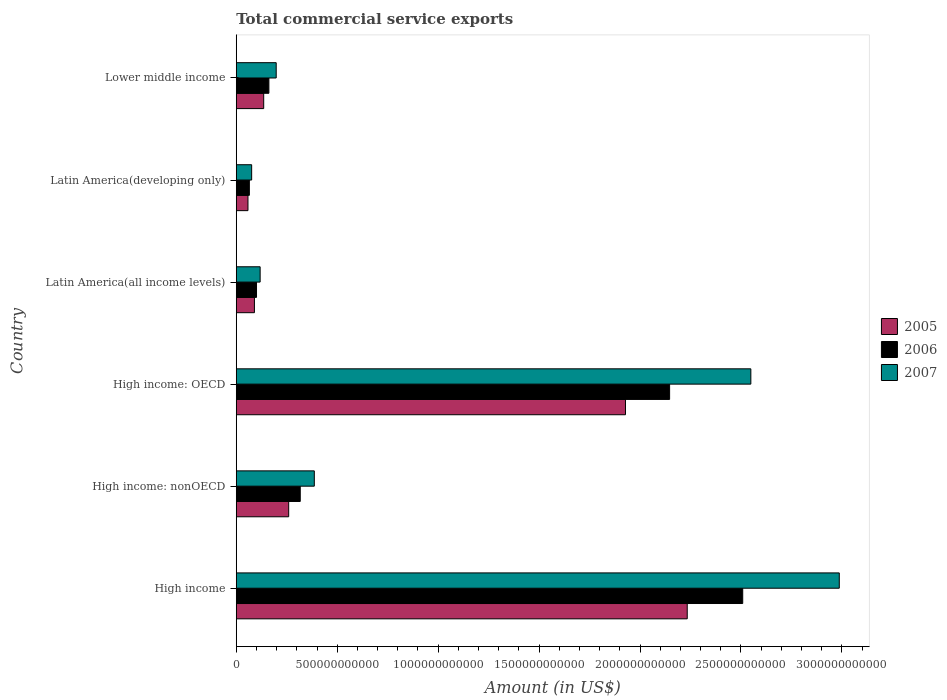Are the number of bars per tick equal to the number of legend labels?
Provide a succinct answer. Yes. How many bars are there on the 6th tick from the top?
Ensure brevity in your answer.  3. What is the label of the 6th group of bars from the top?
Keep it short and to the point. High income. What is the total commercial service exports in 2006 in Latin America(developing only)?
Provide a succinct answer. 6.49e+1. Across all countries, what is the maximum total commercial service exports in 2005?
Make the answer very short. 2.23e+12. Across all countries, what is the minimum total commercial service exports in 2006?
Your answer should be very brief. 6.49e+1. In which country was the total commercial service exports in 2006 minimum?
Make the answer very short. Latin America(developing only). What is the total total commercial service exports in 2005 in the graph?
Provide a short and direct response. 4.71e+12. What is the difference between the total commercial service exports in 2007 in High income: OECD and that in Latin America(developing only)?
Provide a short and direct response. 2.47e+12. What is the difference between the total commercial service exports in 2006 in High income: OECD and the total commercial service exports in 2005 in High income: nonOECD?
Provide a short and direct response. 1.89e+12. What is the average total commercial service exports in 2005 per country?
Your answer should be very brief. 7.84e+11. What is the difference between the total commercial service exports in 2007 and total commercial service exports in 2006 in Lower middle income?
Provide a short and direct response. 3.62e+1. What is the ratio of the total commercial service exports in 2005 in High income: OECD to that in Lower middle income?
Your answer should be compact. 14.18. Is the difference between the total commercial service exports in 2007 in High income and High income: OECD greater than the difference between the total commercial service exports in 2006 in High income and High income: OECD?
Give a very brief answer. Yes. What is the difference between the highest and the second highest total commercial service exports in 2006?
Your answer should be very brief. 3.62e+11. What is the difference between the highest and the lowest total commercial service exports in 2007?
Make the answer very short. 2.91e+12. Is the sum of the total commercial service exports in 2005 in High income and High income: OECD greater than the maximum total commercial service exports in 2006 across all countries?
Your answer should be compact. Yes. What does the 2nd bar from the top in High income represents?
Your response must be concise. 2006. Is it the case that in every country, the sum of the total commercial service exports in 2006 and total commercial service exports in 2005 is greater than the total commercial service exports in 2007?
Give a very brief answer. Yes. How many bars are there?
Provide a short and direct response. 18. Are all the bars in the graph horizontal?
Provide a short and direct response. Yes. How many countries are there in the graph?
Your response must be concise. 6. What is the difference between two consecutive major ticks on the X-axis?
Your response must be concise. 5.00e+11. Are the values on the major ticks of X-axis written in scientific E-notation?
Offer a very short reply. No. Does the graph contain any zero values?
Provide a succinct answer. No. Does the graph contain grids?
Provide a short and direct response. No. Where does the legend appear in the graph?
Offer a terse response. Center right. How are the legend labels stacked?
Give a very brief answer. Vertical. What is the title of the graph?
Your answer should be compact. Total commercial service exports. Does "1981" appear as one of the legend labels in the graph?
Your answer should be compact. No. What is the label or title of the X-axis?
Give a very brief answer. Amount (in US$). What is the Amount (in US$) in 2005 in High income?
Offer a very short reply. 2.23e+12. What is the Amount (in US$) of 2006 in High income?
Offer a very short reply. 2.51e+12. What is the Amount (in US$) of 2007 in High income?
Offer a very short reply. 2.99e+12. What is the Amount (in US$) in 2005 in High income: nonOECD?
Your answer should be very brief. 2.60e+11. What is the Amount (in US$) of 2006 in High income: nonOECD?
Keep it short and to the point. 3.17e+11. What is the Amount (in US$) in 2007 in High income: nonOECD?
Offer a terse response. 3.87e+11. What is the Amount (in US$) of 2005 in High income: OECD?
Offer a very short reply. 1.93e+12. What is the Amount (in US$) of 2006 in High income: OECD?
Your response must be concise. 2.15e+12. What is the Amount (in US$) in 2007 in High income: OECD?
Provide a short and direct response. 2.55e+12. What is the Amount (in US$) of 2005 in Latin America(all income levels)?
Ensure brevity in your answer.  9.00e+1. What is the Amount (in US$) of 2006 in Latin America(all income levels)?
Your answer should be very brief. 1.00e+11. What is the Amount (in US$) of 2007 in Latin America(all income levels)?
Offer a terse response. 1.18e+11. What is the Amount (in US$) in 2005 in Latin America(developing only)?
Your response must be concise. 5.80e+1. What is the Amount (in US$) in 2006 in Latin America(developing only)?
Make the answer very short. 6.49e+1. What is the Amount (in US$) of 2007 in Latin America(developing only)?
Provide a short and direct response. 7.63e+1. What is the Amount (in US$) in 2005 in Lower middle income?
Keep it short and to the point. 1.36e+11. What is the Amount (in US$) in 2006 in Lower middle income?
Make the answer very short. 1.62e+11. What is the Amount (in US$) of 2007 in Lower middle income?
Your answer should be very brief. 1.98e+11. Across all countries, what is the maximum Amount (in US$) in 2005?
Provide a succinct answer. 2.23e+12. Across all countries, what is the maximum Amount (in US$) of 2006?
Your answer should be compact. 2.51e+12. Across all countries, what is the maximum Amount (in US$) of 2007?
Offer a terse response. 2.99e+12. Across all countries, what is the minimum Amount (in US$) of 2005?
Keep it short and to the point. 5.80e+1. Across all countries, what is the minimum Amount (in US$) of 2006?
Your response must be concise. 6.49e+1. Across all countries, what is the minimum Amount (in US$) of 2007?
Your response must be concise. 7.63e+1. What is the total Amount (in US$) in 2005 in the graph?
Offer a terse response. 4.71e+12. What is the total Amount (in US$) in 2006 in the graph?
Your response must be concise. 5.30e+12. What is the total Amount (in US$) of 2007 in the graph?
Provide a short and direct response. 6.31e+12. What is the difference between the Amount (in US$) in 2005 in High income and that in High income: nonOECD?
Ensure brevity in your answer.  1.97e+12. What is the difference between the Amount (in US$) of 2006 in High income and that in High income: nonOECD?
Make the answer very short. 2.19e+12. What is the difference between the Amount (in US$) of 2007 in High income and that in High income: nonOECD?
Keep it short and to the point. 2.60e+12. What is the difference between the Amount (in US$) of 2005 in High income and that in High income: OECD?
Give a very brief answer. 3.06e+11. What is the difference between the Amount (in US$) of 2006 in High income and that in High income: OECD?
Offer a very short reply. 3.62e+11. What is the difference between the Amount (in US$) of 2007 in High income and that in High income: OECD?
Offer a terse response. 4.38e+11. What is the difference between the Amount (in US$) in 2005 in High income and that in Latin America(all income levels)?
Your answer should be compact. 2.14e+12. What is the difference between the Amount (in US$) in 2006 in High income and that in Latin America(all income levels)?
Your response must be concise. 2.41e+12. What is the difference between the Amount (in US$) in 2007 in High income and that in Latin America(all income levels)?
Offer a terse response. 2.87e+12. What is the difference between the Amount (in US$) of 2005 in High income and that in Latin America(developing only)?
Keep it short and to the point. 2.18e+12. What is the difference between the Amount (in US$) in 2006 in High income and that in Latin America(developing only)?
Keep it short and to the point. 2.44e+12. What is the difference between the Amount (in US$) in 2007 in High income and that in Latin America(developing only)?
Provide a short and direct response. 2.91e+12. What is the difference between the Amount (in US$) of 2005 in High income and that in Lower middle income?
Provide a succinct answer. 2.10e+12. What is the difference between the Amount (in US$) in 2006 in High income and that in Lower middle income?
Offer a terse response. 2.35e+12. What is the difference between the Amount (in US$) of 2007 in High income and that in Lower middle income?
Make the answer very short. 2.79e+12. What is the difference between the Amount (in US$) of 2005 in High income: nonOECD and that in High income: OECD?
Offer a terse response. -1.67e+12. What is the difference between the Amount (in US$) in 2006 in High income: nonOECD and that in High income: OECD?
Your answer should be very brief. -1.83e+12. What is the difference between the Amount (in US$) of 2007 in High income: nonOECD and that in High income: OECD?
Your response must be concise. -2.16e+12. What is the difference between the Amount (in US$) in 2005 in High income: nonOECD and that in Latin America(all income levels)?
Offer a very short reply. 1.70e+11. What is the difference between the Amount (in US$) in 2006 in High income: nonOECD and that in Latin America(all income levels)?
Ensure brevity in your answer.  2.17e+11. What is the difference between the Amount (in US$) in 2007 in High income: nonOECD and that in Latin America(all income levels)?
Ensure brevity in your answer.  2.68e+11. What is the difference between the Amount (in US$) of 2005 in High income: nonOECD and that in Latin America(developing only)?
Make the answer very short. 2.02e+11. What is the difference between the Amount (in US$) of 2006 in High income: nonOECD and that in Latin America(developing only)?
Provide a succinct answer. 2.52e+11. What is the difference between the Amount (in US$) of 2007 in High income: nonOECD and that in Latin America(developing only)?
Offer a terse response. 3.10e+11. What is the difference between the Amount (in US$) in 2005 in High income: nonOECD and that in Lower middle income?
Your answer should be compact. 1.24e+11. What is the difference between the Amount (in US$) of 2006 in High income: nonOECD and that in Lower middle income?
Keep it short and to the point. 1.55e+11. What is the difference between the Amount (in US$) of 2007 in High income: nonOECD and that in Lower middle income?
Ensure brevity in your answer.  1.89e+11. What is the difference between the Amount (in US$) in 2005 in High income: OECD and that in Latin America(all income levels)?
Make the answer very short. 1.84e+12. What is the difference between the Amount (in US$) in 2006 in High income: OECD and that in Latin America(all income levels)?
Keep it short and to the point. 2.05e+12. What is the difference between the Amount (in US$) in 2007 in High income: OECD and that in Latin America(all income levels)?
Ensure brevity in your answer.  2.43e+12. What is the difference between the Amount (in US$) of 2005 in High income: OECD and that in Latin America(developing only)?
Offer a very short reply. 1.87e+12. What is the difference between the Amount (in US$) in 2006 in High income: OECD and that in Latin America(developing only)?
Offer a very short reply. 2.08e+12. What is the difference between the Amount (in US$) of 2007 in High income: OECD and that in Latin America(developing only)?
Keep it short and to the point. 2.47e+12. What is the difference between the Amount (in US$) in 2005 in High income: OECD and that in Lower middle income?
Your answer should be compact. 1.79e+12. What is the difference between the Amount (in US$) of 2006 in High income: OECD and that in Lower middle income?
Ensure brevity in your answer.  1.98e+12. What is the difference between the Amount (in US$) in 2007 in High income: OECD and that in Lower middle income?
Provide a short and direct response. 2.35e+12. What is the difference between the Amount (in US$) in 2005 in Latin America(all income levels) and that in Latin America(developing only)?
Offer a very short reply. 3.20e+1. What is the difference between the Amount (in US$) of 2006 in Latin America(all income levels) and that in Latin America(developing only)?
Provide a short and direct response. 3.54e+1. What is the difference between the Amount (in US$) of 2007 in Latin America(all income levels) and that in Latin America(developing only)?
Provide a short and direct response. 4.20e+1. What is the difference between the Amount (in US$) of 2005 in Latin America(all income levels) and that in Lower middle income?
Keep it short and to the point. -4.60e+1. What is the difference between the Amount (in US$) of 2006 in Latin America(all income levels) and that in Lower middle income?
Provide a short and direct response. -6.13e+1. What is the difference between the Amount (in US$) of 2007 in Latin America(all income levels) and that in Lower middle income?
Keep it short and to the point. -7.96e+1. What is the difference between the Amount (in US$) in 2005 in Latin America(developing only) and that in Lower middle income?
Provide a succinct answer. -7.80e+1. What is the difference between the Amount (in US$) in 2006 in Latin America(developing only) and that in Lower middle income?
Your answer should be very brief. -9.68e+1. What is the difference between the Amount (in US$) of 2007 in Latin America(developing only) and that in Lower middle income?
Offer a terse response. -1.22e+11. What is the difference between the Amount (in US$) in 2005 in High income and the Amount (in US$) in 2006 in High income: nonOECD?
Ensure brevity in your answer.  1.92e+12. What is the difference between the Amount (in US$) of 2005 in High income and the Amount (in US$) of 2007 in High income: nonOECD?
Give a very brief answer. 1.85e+12. What is the difference between the Amount (in US$) of 2006 in High income and the Amount (in US$) of 2007 in High income: nonOECD?
Your answer should be very brief. 2.12e+12. What is the difference between the Amount (in US$) of 2005 in High income and the Amount (in US$) of 2006 in High income: OECD?
Make the answer very short. 8.74e+1. What is the difference between the Amount (in US$) of 2005 in High income and the Amount (in US$) of 2007 in High income: OECD?
Provide a short and direct response. -3.15e+11. What is the difference between the Amount (in US$) in 2006 in High income and the Amount (in US$) in 2007 in High income: OECD?
Ensure brevity in your answer.  -4.02e+1. What is the difference between the Amount (in US$) of 2005 in High income and the Amount (in US$) of 2006 in Latin America(all income levels)?
Provide a succinct answer. 2.13e+12. What is the difference between the Amount (in US$) of 2005 in High income and the Amount (in US$) of 2007 in Latin America(all income levels)?
Keep it short and to the point. 2.12e+12. What is the difference between the Amount (in US$) of 2006 in High income and the Amount (in US$) of 2007 in Latin America(all income levels)?
Ensure brevity in your answer.  2.39e+12. What is the difference between the Amount (in US$) in 2005 in High income and the Amount (in US$) in 2006 in Latin America(developing only)?
Provide a succinct answer. 2.17e+12. What is the difference between the Amount (in US$) in 2005 in High income and the Amount (in US$) in 2007 in Latin America(developing only)?
Give a very brief answer. 2.16e+12. What is the difference between the Amount (in US$) in 2006 in High income and the Amount (in US$) in 2007 in Latin America(developing only)?
Ensure brevity in your answer.  2.43e+12. What is the difference between the Amount (in US$) in 2005 in High income and the Amount (in US$) in 2006 in Lower middle income?
Your answer should be very brief. 2.07e+12. What is the difference between the Amount (in US$) in 2005 in High income and the Amount (in US$) in 2007 in Lower middle income?
Keep it short and to the point. 2.04e+12. What is the difference between the Amount (in US$) in 2006 in High income and the Amount (in US$) in 2007 in Lower middle income?
Ensure brevity in your answer.  2.31e+12. What is the difference between the Amount (in US$) of 2005 in High income: nonOECD and the Amount (in US$) of 2006 in High income: OECD?
Make the answer very short. -1.89e+12. What is the difference between the Amount (in US$) of 2005 in High income: nonOECD and the Amount (in US$) of 2007 in High income: OECD?
Provide a short and direct response. -2.29e+12. What is the difference between the Amount (in US$) of 2006 in High income: nonOECD and the Amount (in US$) of 2007 in High income: OECD?
Make the answer very short. -2.23e+12. What is the difference between the Amount (in US$) of 2005 in High income: nonOECD and the Amount (in US$) of 2006 in Latin America(all income levels)?
Keep it short and to the point. 1.59e+11. What is the difference between the Amount (in US$) in 2005 in High income: nonOECD and the Amount (in US$) in 2007 in Latin America(all income levels)?
Make the answer very short. 1.41e+11. What is the difference between the Amount (in US$) in 2006 in High income: nonOECD and the Amount (in US$) in 2007 in Latin America(all income levels)?
Give a very brief answer. 1.99e+11. What is the difference between the Amount (in US$) of 2005 in High income: nonOECD and the Amount (in US$) of 2006 in Latin America(developing only)?
Make the answer very short. 1.95e+11. What is the difference between the Amount (in US$) in 2005 in High income: nonOECD and the Amount (in US$) in 2007 in Latin America(developing only)?
Provide a short and direct response. 1.83e+11. What is the difference between the Amount (in US$) in 2006 in High income: nonOECD and the Amount (in US$) in 2007 in Latin America(developing only)?
Your answer should be very brief. 2.41e+11. What is the difference between the Amount (in US$) in 2005 in High income: nonOECD and the Amount (in US$) in 2006 in Lower middle income?
Your answer should be compact. 9.80e+1. What is the difference between the Amount (in US$) of 2005 in High income: nonOECD and the Amount (in US$) of 2007 in Lower middle income?
Provide a short and direct response. 6.18e+1. What is the difference between the Amount (in US$) in 2006 in High income: nonOECD and the Amount (in US$) in 2007 in Lower middle income?
Your answer should be very brief. 1.19e+11. What is the difference between the Amount (in US$) in 2005 in High income: OECD and the Amount (in US$) in 2006 in Latin America(all income levels)?
Give a very brief answer. 1.83e+12. What is the difference between the Amount (in US$) in 2005 in High income: OECD and the Amount (in US$) in 2007 in Latin America(all income levels)?
Provide a short and direct response. 1.81e+12. What is the difference between the Amount (in US$) of 2006 in High income: OECD and the Amount (in US$) of 2007 in Latin America(all income levels)?
Offer a terse response. 2.03e+12. What is the difference between the Amount (in US$) in 2005 in High income: OECD and the Amount (in US$) in 2006 in Latin America(developing only)?
Your response must be concise. 1.86e+12. What is the difference between the Amount (in US$) in 2005 in High income: OECD and the Amount (in US$) in 2007 in Latin America(developing only)?
Keep it short and to the point. 1.85e+12. What is the difference between the Amount (in US$) in 2006 in High income: OECD and the Amount (in US$) in 2007 in Latin America(developing only)?
Your response must be concise. 2.07e+12. What is the difference between the Amount (in US$) of 2005 in High income: OECD and the Amount (in US$) of 2006 in Lower middle income?
Ensure brevity in your answer.  1.77e+12. What is the difference between the Amount (in US$) of 2005 in High income: OECD and the Amount (in US$) of 2007 in Lower middle income?
Keep it short and to the point. 1.73e+12. What is the difference between the Amount (in US$) in 2006 in High income: OECD and the Amount (in US$) in 2007 in Lower middle income?
Ensure brevity in your answer.  1.95e+12. What is the difference between the Amount (in US$) of 2005 in Latin America(all income levels) and the Amount (in US$) of 2006 in Latin America(developing only)?
Your answer should be very brief. 2.51e+1. What is the difference between the Amount (in US$) of 2005 in Latin America(all income levels) and the Amount (in US$) of 2007 in Latin America(developing only)?
Make the answer very short. 1.37e+1. What is the difference between the Amount (in US$) of 2006 in Latin America(all income levels) and the Amount (in US$) of 2007 in Latin America(developing only)?
Your answer should be compact. 2.40e+1. What is the difference between the Amount (in US$) in 2005 in Latin America(all income levels) and the Amount (in US$) in 2006 in Lower middle income?
Your answer should be very brief. -7.16e+1. What is the difference between the Amount (in US$) of 2005 in Latin America(all income levels) and the Amount (in US$) of 2007 in Lower middle income?
Your answer should be very brief. -1.08e+11. What is the difference between the Amount (in US$) in 2006 in Latin America(all income levels) and the Amount (in US$) in 2007 in Lower middle income?
Provide a succinct answer. -9.75e+1. What is the difference between the Amount (in US$) of 2005 in Latin America(developing only) and the Amount (in US$) of 2006 in Lower middle income?
Make the answer very short. -1.04e+11. What is the difference between the Amount (in US$) of 2005 in Latin America(developing only) and the Amount (in US$) of 2007 in Lower middle income?
Ensure brevity in your answer.  -1.40e+11. What is the difference between the Amount (in US$) in 2006 in Latin America(developing only) and the Amount (in US$) in 2007 in Lower middle income?
Your answer should be compact. -1.33e+11. What is the average Amount (in US$) in 2005 per country?
Ensure brevity in your answer.  7.84e+11. What is the average Amount (in US$) of 2006 per country?
Make the answer very short. 8.83e+11. What is the average Amount (in US$) of 2007 per country?
Give a very brief answer. 1.05e+12. What is the difference between the Amount (in US$) in 2005 and Amount (in US$) in 2006 in High income?
Your answer should be very brief. -2.75e+11. What is the difference between the Amount (in US$) of 2005 and Amount (in US$) of 2007 in High income?
Your response must be concise. -7.53e+11. What is the difference between the Amount (in US$) in 2006 and Amount (in US$) in 2007 in High income?
Make the answer very short. -4.78e+11. What is the difference between the Amount (in US$) of 2005 and Amount (in US$) of 2006 in High income: nonOECD?
Your response must be concise. -5.73e+1. What is the difference between the Amount (in US$) in 2005 and Amount (in US$) in 2007 in High income: nonOECD?
Provide a short and direct response. -1.27e+11. What is the difference between the Amount (in US$) in 2006 and Amount (in US$) in 2007 in High income: nonOECD?
Provide a short and direct response. -6.97e+1. What is the difference between the Amount (in US$) of 2005 and Amount (in US$) of 2006 in High income: OECD?
Your response must be concise. -2.19e+11. What is the difference between the Amount (in US$) of 2005 and Amount (in US$) of 2007 in High income: OECD?
Your response must be concise. -6.21e+11. What is the difference between the Amount (in US$) in 2006 and Amount (in US$) in 2007 in High income: OECD?
Provide a succinct answer. -4.02e+11. What is the difference between the Amount (in US$) of 2005 and Amount (in US$) of 2006 in Latin America(all income levels)?
Offer a very short reply. -1.03e+1. What is the difference between the Amount (in US$) of 2005 and Amount (in US$) of 2007 in Latin America(all income levels)?
Make the answer very short. -2.83e+1. What is the difference between the Amount (in US$) of 2006 and Amount (in US$) of 2007 in Latin America(all income levels)?
Your response must be concise. -1.80e+1. What is the difference between the Amount (in US$) of 2005 and Amount (in US$) of 2006 in Latin America(developing only)?
Offer a terse response. -6.88e+09. What is the difference between the Amount (in US$) in 2005 and Amount (in US$) in 2007 in Latin America(developing only)?
Make the answer very short. -1.83e+1. What is the difference between the Amount (in US$) of 2006 and Amount (in US$) of 2007 in Latin America(developing only)?
Offer a terse response. -1.14e+1. What is the difference between the Amount (in US$) of 2005 and Amount (in US$) of 2006 in Lower middle income?
Offer a terse response. -2.57e+1. What is the difference between the Amount (in US$) of 2005 and Amount (in US$) of 2007 in Lower middle income?
Provide a succinct answer. -6.19e+1. What is the difference between the Amount (in US$) in 2006 and Amount (in US$) in 2007 in Lower middle income?
Provide a succinct answer. -3.62e+1. What is the ratio of the Amount (in US$) of 2005 in High income to that in High income: nonOECD?
Your answer should be very brief. 8.6. What is the ratio of the Amount (in US$) of 2006 in High income to that in High income: nonOECD?
Your response must be concise. 7.91. What is the ratio of the Amount (in US$) in 2007 in High income to that in High income: nonOECD?
Provide a short and direct response. 7.72. What is the ratio of the Amount (in US$) in 2005 in High income to that in High income: OECD?
Give a very brief answer. 1.16. What is the ratio of the Amount (in US$) of 2006 in High income to that in High income: OECD?
Your answer should be compact. 1.17. What is the ratio of the Amount (in US$) in 2007 in High income to that in High income: OECD?
Your answer should be very brief. 1.17. What is the ratio of the Amount (in US$) of 2005 in High income to that in Latin America(all income levels)?
Your answer should be compact. 24.82. What is the ratio of the Amount (in US$) of 2006 in High income to that in Latin America(all income levels)?
Offer a very short reply. 25. What is the ratio of the Amount (in US$) in 2007 in High income to that in Latin America(all income levels)?
Your response must be concise. 25.25. What is the ratio of the Amount (in US$) in 2005 in High income to that in Latin America(developing only)?
Offer a very short reply. 38.51. What is the ratio of the Amount (in US$) in 2006 in High income to that in Latin America(developing only)?
Provide a succinct answer. 38.67. What is the ratio of the Amount (in US$) in 2007 in High income to that in Latin America(developing only)?
Offer a terse response. 39.15. What is the ratio of the Amount (in US$) in 2005 in High income to that in Lower middle income?
Make the answer very short. 16.43. What is the ratio of the Amount (in US$) in 2006 in High income to that in Lower middle income?
Your answer should be compact. 15.52. What is the ratio of the Amount (in US$) in 2007 in High income to that in Lower middle income?
Your answer should be very brief. 15.09. What is the ratio of the Amount (in US$) in 2005 in High income: nonOECD to that in High income: OECD?
Offer a very short reply. 0.13. What is the ratio of the Amount (in US$) in 2006 in High income: nonOECD to that in High income: OECD?
Your answer should be very brief. 0.15. What is the ratio of the Amount (in US$) in 2007 in High income: nonOECD to that in High income: OECD?
Provide a short and direct response. 0.15. What is the ratio of the Amount (in US$) of 2005 in High income: nonOECD to that in Latin America(all income levels)?
Offer a terse response. 2.89. What is the ratio of the Amount (in US$) in 2006 in High income: nonOECD to that in Latin America(all income levels)?
Your response must be concise. 3.16. What is the ratio of the Amount (in US$) in 2007 in High income: nonOECD to that in Latin America(all income levels)?
Provide a short and direct response. 3.27. What is the ratio of the Amount (in US$) of 2005 in High income: nonOECD to that in Latin America(developing only)?
Provide a succinct answer. 4.48. What is the ratio of the Amount (in US$) of 2006 in High income: nonOECD to that in Latin America(developing only)?
Provide a succinct answer. 4.89. What is the ratio of the Amount (in US$) of 2007 in High income: nonOECD to that in Latin America(developing only)?
Your answer should be compact. 5.07. What is the ratio of the Amount (in US$) of 2005 in High income: nonOECD to that in Lower middle income?
Your answer should be very brief. 1.91. What is the ratio of the Amount (in US$) in 2006 in High income: nonOECD to that in Lower middle income?
Keep it short and to the point. 1.96. What is the ratio of the Amount (in US$) of 2007 in High income: nonOECD to that in Lower middle income?
Your answer should be compact. 1.95. What is the ratio of the Amount (in US$) of 2005 in High income: OECD to that in Latin America(all income levels)?
Keep it short and to the point. 21.42. What is the ratio of the Amount (in US$) of 2006 in High income: OECD to that in Latin America(all income levels)?
Your answer should be very brief. 21.39. What is the ratio of the Amount (in US$) of 2007 in High income: OECD to that in Latin America(all income levels)?
Your answer should be compact. 21.54. What is the ratio of the Amount (in US$) in 2005 in High income: OECD to that in Latin America(developing only)?
Offer a terse response. 33.24. What is the ratio of the Amount (in US$) in 2006 in High income: OECD to that in Latin America(developing only)?
Offer a very short reply. 33.08. What is the ratio of the Amount (in US$) of 2007 in High income: OECD to that in Latin America(developing only)?
Offer a terse response. 33.41. What is the ratio of the Amount (in US$) of 2005 in High income: OECD to that in Lower middle income?
Your response must be concise. 14.18. What is the ratio of the Amount (in US$) of 2006 in High income: OECD to that in Lower middle income?
Offer a terse response. 13.28. What is the ratio of the Amount (in US$) of 2007 in High income: OECD to that in Lower middle income?
Keep it short and to the point. 12.88. What is the ratio of the Amount (in US$) in 2005 in Latin America(all income levels) to that in Latin America(developing only)?
Provide a short and direct response. 1.55. What is the ratio of the Amount (in US$) of 2006 in Latin America(all income levels) to that in Latin America(developing only)?
Provide a succinct answer. 1.55. What is the ratio of the Amount (in US$) of 2007 in Latin America(all income levels) to that in Latin America(developing only)?
Ensure brevity in your answer.  1.55. What is the ratio of the Amount (in US$) in 2005 in Latin America(all income levels) to that in Lower middle income?
Give a very brief answer. 0.66. What is the ratio of the Amount (in US$) of 2006 in Latin America(all income levels) to that in Lower middle income?
Offer a very short reply. 0.62. What is the ratio of the Amount (in US$) of 2007 in Latin America(all income levels) to that in Lower middle income?
Offer a very short reply. 0.6. What is the ratio of the Amount (in US$) in 2005 in Latin America(developing only) to that in Lower middle income?
Provide a succinct answer. 0.43. What is the ratio of the Amount (in US$) of 2006 in Latin America(developing only) to that in Lower middle income?
Offer a very short reply. 0.4. What is the ratio of the Amount (in US$) of 2007 in Latin America(developing only) to that in Lower middle income?
Offer a very short reply. 0.39. What is the difference between the highest and the second highest Amount (in US$) in 2005?
Keep it short and to the point. 3.06e+11. What is the difference between the highest and the second highest Amount (in US$) in 2006?
Provide a succinct answer. 3.62e+11. What is the difference between the highest and the second highest Amount (in US$) in 2007?
Provide a short and direct response. 4.38e+11. What is the difference between the highest and the lowest Amount (in US$) in 2005?
Your response must be concise. 2.18e+12. What is the difference between the highest and the lowest Amount (in US$) of 2006?
Your response must be concise. 2.44e+12. What is the difference between the highest and the lowest Amount (in US$) in 2007?
Ensure brevity in your answer.  2.91e+12. 